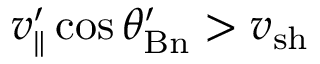Convert formula to latex. <formula><loc_0><loc_0><loc_500><loc_500>v _ { \| } ^ { \prime } \cos \theta _ { B n } ^ { \prime } > v _ { s h }</formula> 